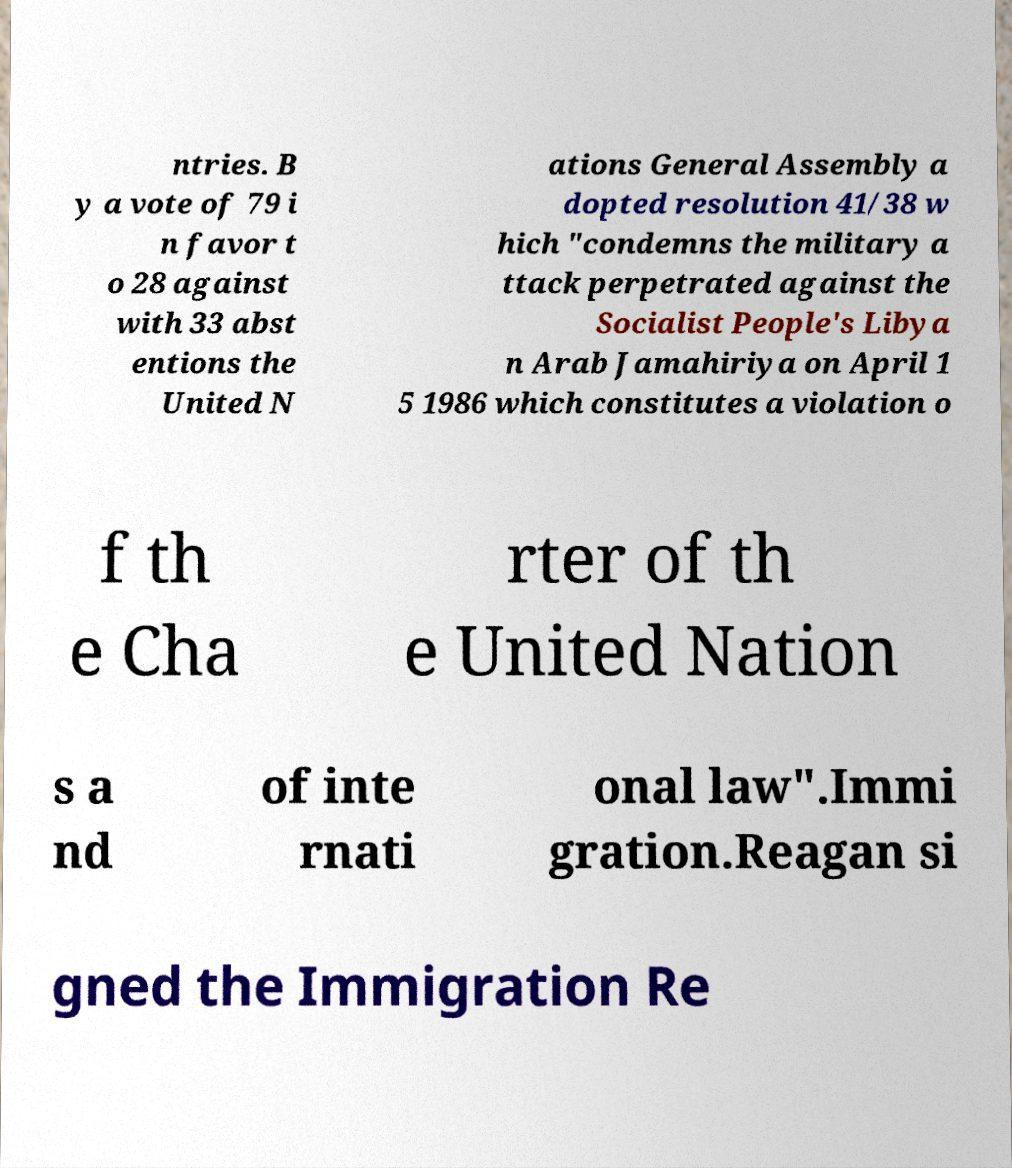Could you assist in decoding the text presented in this image and type it out clearly? ntries. B y a vote of 79 i n favor t o 28 against with 33 abst entions the United N ations General Assembly a dopted resolution 41/38 w hich "condemns the military a ttack perpetrated against the Socialist People's Libya n Arab Jamahiriya on April 1 5 1986 which constitutes a violation o f th e Cha rter of th e United Nation s a nd of inte rnati onal law".Immi gration.Reagan si gned the Immigration Re 